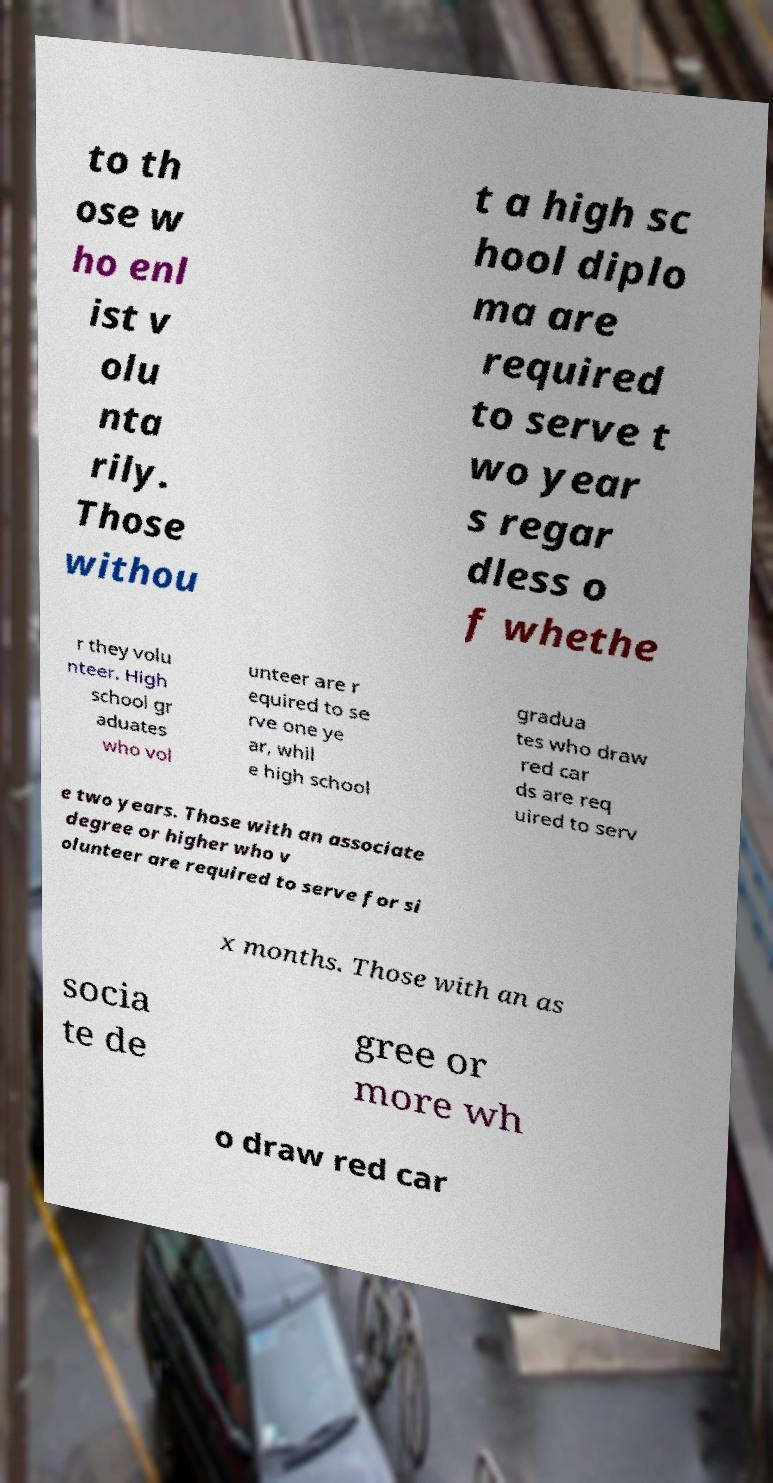Could you assist in decoding the text presented in this image and type it out clearly? to th ose w ho enl ist v olu nta rily. Those withou t a high sc hool diplo ma are required to serve t wo year s regar dless o f whethe r they volu nteer. High school gr aduates who vol unteer are r equired to se rve one ye ar, whil e high school gradua tes who draw red car ds are req uired to serv e two years. Those with an associate degree or higher who v olunteer are required to serve for si x months. Those with an as socia te de gree or more wh o draw red car 